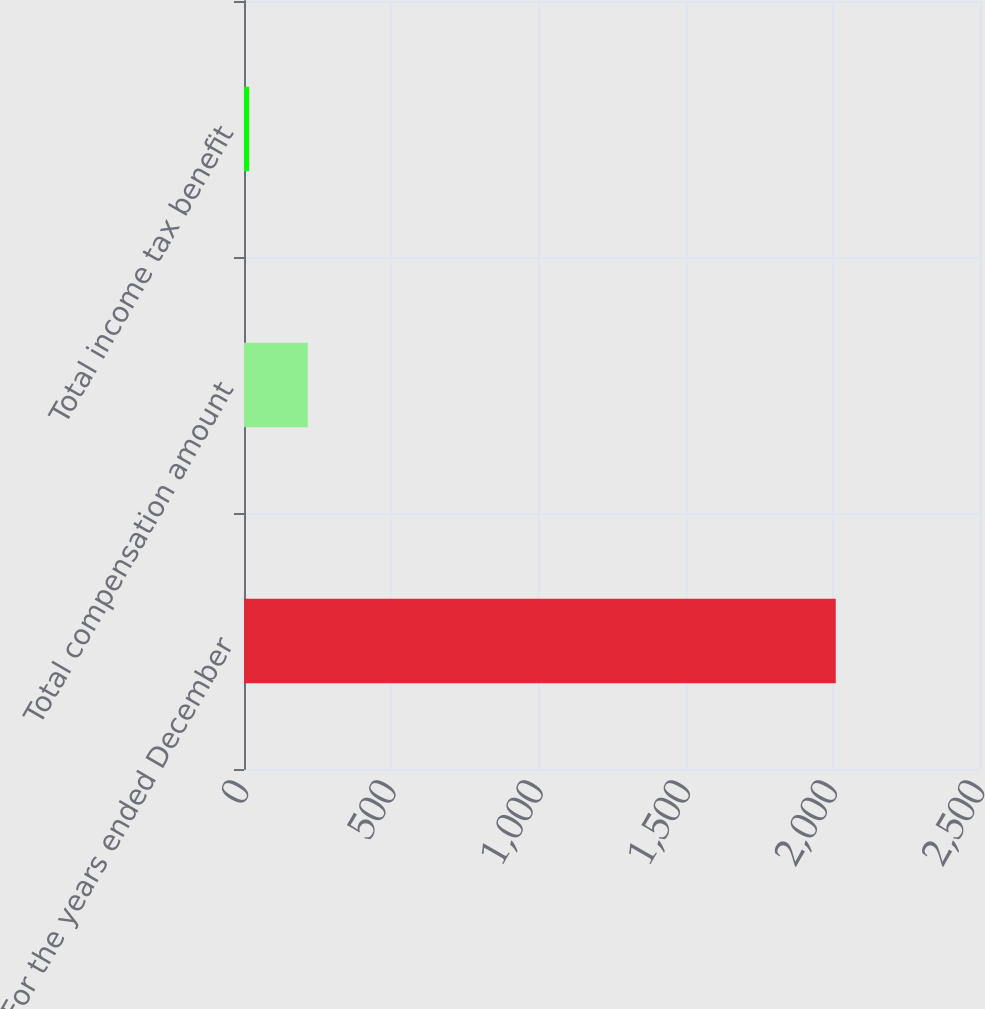Convert chart to OTSL. <chart><loc_0><loc_0><loc_500><loc_500><bar_chart><fcel>For the years ended December<fcel>Total compensation amount<fcel>Total income tax benefit<nl><fcel>2010<fcel>216.66<fcel>17.4<nl></chart> 